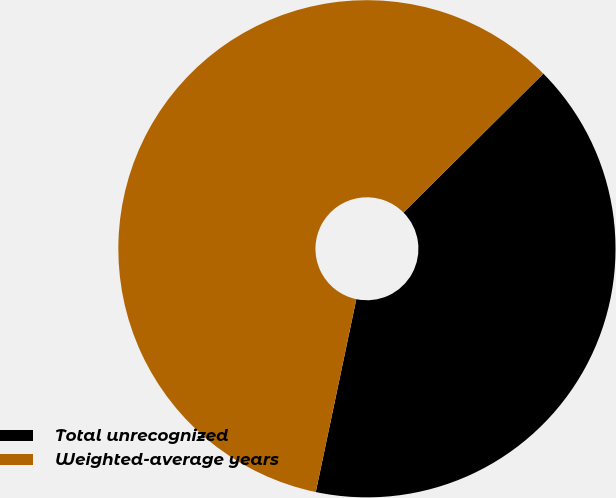<chart> <loc_0><loc_0><loc_500><loc_500><pie_chart><fcel>Total unrecognized<fcel>Weighted-average years<nl><fcel>40.74%<fcel>59.26%<nl></chart> 